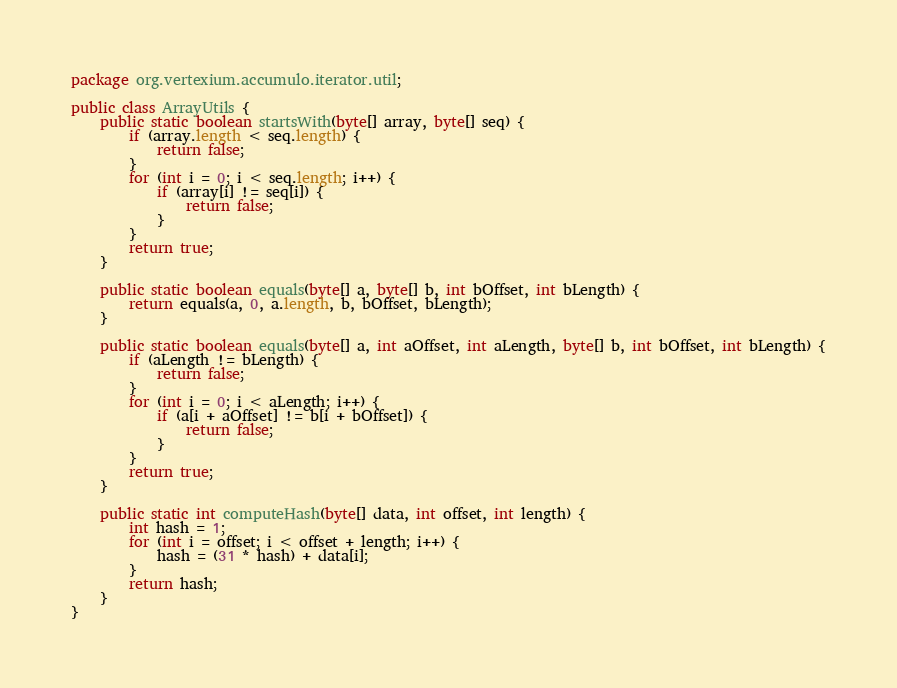<code> <loc_0><loc_0><loc_500><loc_500><_Java_>package org.vertexium.accumulo.iterator.util;

public class ArrayUtils {
    public static boolean startsWith(byte[] array, byte[] seq) {
        if (array.length < seq.length) {
            return false;
        }
        for (int i = 0; i < seq.length; i++) {
            if (array[i] != seq[i]) {
                return false;
            }
        }
        return true;
    }

    public static boolean equals(byte[] a, byte[] b, int bOffset, int bLength) {
        return equals(a, 0, a.length, b, bOffset, bLength);
    }

    public static boolean equals(byte[] a, int aOffset, int aLength, byte[] b, int bOffset, int bLength) {
        if (aLength != bLength) {
            return false;
        }
        for (int i = 0; i < aLength; i++) {
            if (a[i + aOffset] != b[i + bOffset]) {
                return false;
            }
        }
        return true;
    }

    public static int computeHash(byte[] data, int offset, int length) {
        int hash = 1;
        for (int i = offset; i < offset + length; i++) {
            hash = (31 * hash) + data[i];
        }
        return hash;
    }
}
</code> 